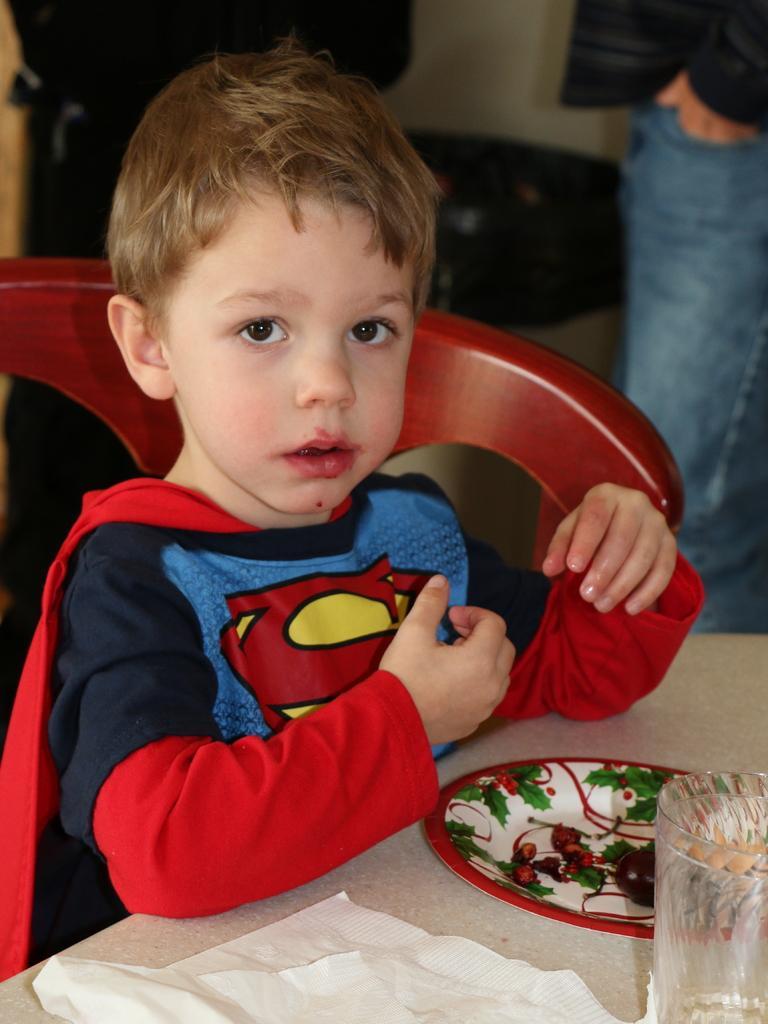Can you describe this image briefly? In this image we can see a boy wearing a costume and sitting, before him there is a table and we can see a plate, tissue and a glass placed on the table. In the background there are people. 